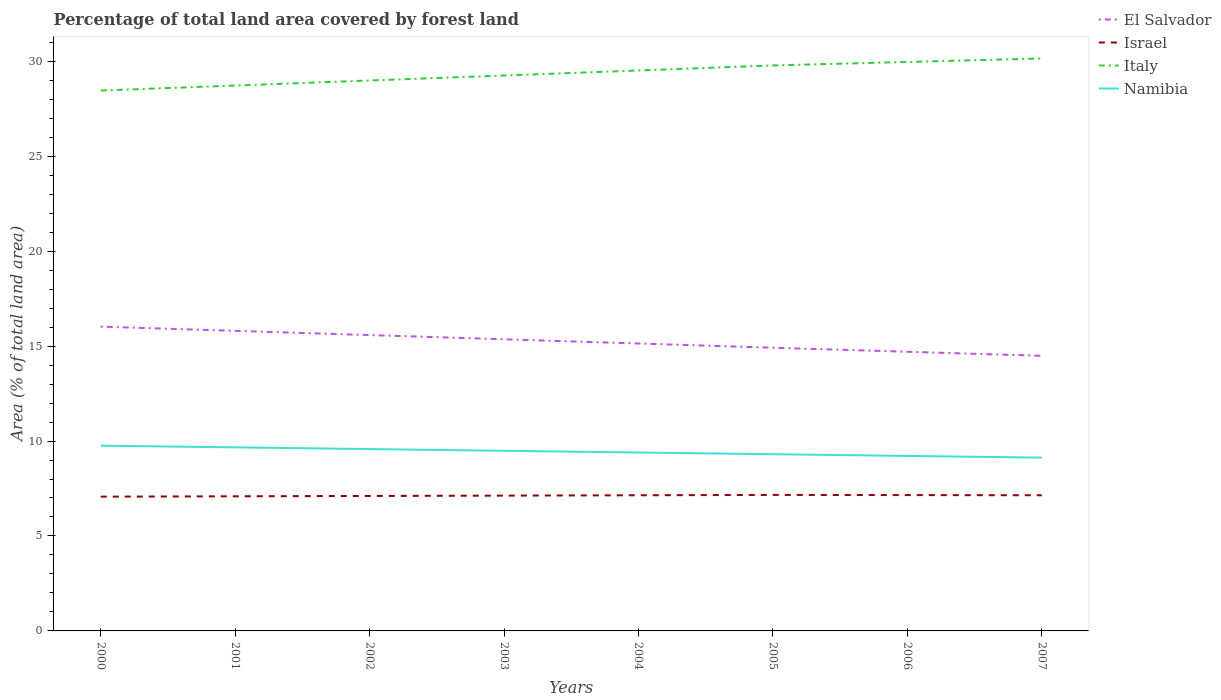How many different coloured lines are there?
Your answer should be compact. 4. Is the number of lines equal to the number of legend labels?
Provide a short and direct response. Yes. Across all years, what is the maximum percentage of forest land in Italy?
Provide a succinct answer. 28.46. In which year was the percentage of forest land in Namibia maximum?
Give a very brief answer. 2007. What is the total percentage of forest land in Israel in the graph?
Offer a terse response. -0.06. What is the difference between the highest and the second highest percentage of forest land in El Salvador?
Ensure brevity in your answer.  1.53. How many lines are there?
Offer a terse response. 4. How many years are there in the graph?
Provide a short and direct response. 8. Does the graph contain any zero values?
Provide a succinct answer. No. Does the graph contain grids?
Keep it short and to the point. No. How many legend labels are there?
Your response must be concise. 4. How are the legend labels stacked?
Your answer should be very brief. Vertical. What is the title of the graph?
Provide a short and direct response. Percentage of total land area covered by forest land. Does "Korea (Republic)" appear as one of the legend labels in the graph?
Your answer should be very brief. No. What is the label or title of the Y-axis?
Provide a succinct answer. Area (% of total land area). What is the Area (% of total land area) in El Salvador in 2000?
Offer a very short reply. 16.02. What is the Area (% of total land area) in Israel in 2000?
Ensure brevity in your answer.  7.07. What is the Area (% of total land area) in Italy in 2000?
Keep it short and to the point. 28.46. What is the Area (% of total land area) in Namibia in 2000?
Provide a short and direct response. 9.76. What is the Area (% of total land area) of El Salvador in 2001?
Provide a succinct answer. 15.8. What is the Area (% of total land area) of Israel in 2001?
Provide a succinct answer. 7.09. What is the Area (% of total land area) in Italy in 2001?
Offer a terse response. 28.72. What is the Area (% of total land area) of Namibia in 2001?
Offer a terse response. 9.67. What is the Area (% of total land area) of El Salvador in 2002?
Ensure brevity in your answer.  15.58. What is the Area (% of total land area) of Israel in 2002?
Offer a terse response. 7.11. What is the Area (% of total land area) in Italy in 2002?
Give a very brief answer. 28.99. What is the Area (% of total land area) in Namibia in 2002?
Provide a succinct answer. 9.58. What is the Area (% of total land area) in El Salvador in 2003?
Provide a short and direct response. 15.36. What is the Area (% of total land area) in Israel in 2003?
Make the answer very short. 7.13. What is the Area (% of total land area) of Italy in 2003?
Provide a short and direct response. 29.25. What is the Area (% of total land area) of Namibia in 2003?
Your answer should be compact. 9.49. What is the Area (% of total land area) in El Salvador in 2004?
Keep it short and to the point. 15.14. What is the Area (% of total land area) in Israel in 2004?
Make the answer very short. 7.14. What is the Area (% of total land area) in Italy in 2004?
Ensure brevity in your answer.  29.51. What is the Area (% of total land area) in Namibia in 2004?
Ensure brevity in your answer.  9.4. What is the Area (% of total land area) in El Salvador in 2005?
Keep it short and to the point. 14.91. What is the Area (% of total land area) of Israel in 2005?
Offer a very short reply. 7.16. What is the Area (% of total land area) of Italy in 2005?
Your response must be concise. 29.78. What is the Area (% of total land area) in Namibia in 2005?
Provide a short and direct response. 9.31. What is the Area (% of total land area) in El Salvador in 2006?
Make the answer very short. 14.7. What is the Area (% of total land area) in Israel in 2006?
Your response must be concise. 7.15. What is the Area (% of total land area) of Italy in 2006?
Ensure brevity in your answer.  29.96. What is the Area (% of total land area) of Namibia in 2006?
Your answer should be compact. 9.22. What is the Area (% of total land area) of El Salvador in 2007?
Offer a very short reply. 14.49. What is the Area (% of total land area) in Israel in 2007?
Give a very brief answer. 7.14. What is the Area (% of total land area) of Italy in 2007?
Offer a terse response. 30.14. What is the Area (% of total land area) of Namibia in 2007?
Provide a succinct answer. 9.13. Across all years, what is the maximum Area (% of total land area) of El Salvador?
Give a very brief answer. 16.02. Across all years, what is the maximum Area (% of total land area) in Israel?
Provide a succinct answer. 7.16. Across all years, what is the maximum Area (% of total land area) in Italy?
Offer a terse response. 30.14. Across all years, what is the maximum Area (% of total land area) of Namibia?
Your answer should be very brief. 9.76. Across all years, what is the minimum Area (% of total land area) of El Salvador?
Make the answer very short. 14.49. Across all years, what is the minimum Area (% of total land area) in Israel?
Offer a terse response. 7.07. Across all years, what is the minimum Area (% of total land area) of Italy?
Provide a short and direct response. 28.46. Across all years, what is the minimum Area (% of total land area) in Namibia?
Provide a short and direct response. 9.13. What is the total Area (% of total land area) of El Salvador in the graph?
Keep it short and to the point. 122. What is the total Area (% of total land area) of Israel in the graph?
Keep it short and to the point. 57. What is the total Area (% of total land area) in Italy in the graph?
Provide a short and direct response. 234.81. What is the total Area (% of total land area) of Namibia in the graph?
Your answer should be compact. 75.52. What is the difference between the Area (% of total land area) of El Salvador in 2000 and that in 2001?
Offer a very short reply. 0.22. What is the difference between the Area (% of total land area) of Israel in 2000 and that in 2001?
Provide a short and direct response. -0.02. What is the difference between the Area (% of total land area) of Italy in 2000 and that in 2001?
Make the answer very short. -0.27. What is the difference between the Area (% of total land area) in Namibia in 2000 and that in 2001?
Ensure brevity in your answer.  0.09. What is the difference between the Area (% of total land area) in El Salvador in 2000 and that in 2002?
Ensure brevity in your answer.  0.44. What is the difference between the Area (% of total land area) of Israel in 2000 and that in 2002?
Offer a very short reply. -0.04. What is the difference between the Area (% of total land area) in Italy in 2000 and that in 2002?
Offer a very short reply. -0.53. What is the difference between the Area (% of total land area) in Namibia in 2000 and that in 2002?
Provide a short and direct response. 0.18. What is the difference between the Area (% of total land area) in El Salvador in 2000 and that in 2003?
Provide a short and direct response. 0.67. What is the difference between the Area (% of total land area) in Israel in 2000 and that in 2003?
Ensure brevity in your answer.  -0.06. What is the difference between the Area (% of total land area) in Italy in 2000 and that in 2003?
Give a very brief answer. -0.79. What is the difference between the Area (% of total land area) in Namibia in 2000 and that in 2003?
Your response must be concise. 0.27. What is the difference between the Area (% of total land area) in El Salvador in 2000 and that in 2004?
Offer a terse response. 0.89. What is the difference between the Area (% of total land area) of Israel in 2000 and that in 2004?
Your answer should be very brief. -0.07. What is the difference between the Area (% of total land area) in Italy in 2000 and that in 2004?
Give a very brief answer. -1.06. What is the difference between the Area (% of total land area) in Namibia in 2000 and that in 2004?
Your answer should be very brief. 0.36. What is the difference between the Area (% of total land area) of El Salvador in 2000 and that in 2005?
Ensure brevity in your answer.  1.11. What is the difference between the Area (% of total land area) in Israel in 2000 and that in 2005?
Your answer should be compact. -0.09. What is the difference between the Area (% of total land area) in Italy in 2000 and that in 2005?
Give a very brief answer. -1.32. What is the difference between the Area (% of total land area) in Namibia in 2000 and that in 2005?
Offer a very short reply. 0.45. What is the difference between the Area (% of total land area) of El Salvador in 2000 and that in 2006?
Offer a very short reply. 1.32. What is the difference between the Area (% of total land area) of Israel in 2000 and that in 2006?
Your answer should be very brief. -0.08. What is the difference between the Area (% of total land area) of Italy in 2000 and that in 2006?
Give a very brief answer. -1.51. What is the difference between the Area (% of total land area) of Namibia in 2000 and that in 2006?
Give a very brief answer. 0.54. What is the difference between the Area (% of total land area) of El Salvador in 2000 and that in 2007?
Offer a terse response. 1.53. What is the difference between the Area (% of total land area) of Israel in 2000 and that in 2007?
Your answer should be very brief. -0.07. What is the difference between the Area (% of total land area) of Italy in 2000 and that in 2007?
Your answer should be compact. -1.69. What is the difference between the Area (% of total land area) in Namibia in 2000 and that in 2007?
Make the answer very short. 0.63. What is the difference between the Area (% of total land area) in El Salvador in 2001 and that in 2002?
Offer a very short reply. 0.22. What is the difference between the Area (% of total land area) in Israel in 2001 and that in 2002?
Your answer should be compact. -0.02. What is the difference between the Area (% of total land area) in Italy in 2001 and that in 2002?
Ensure brevity in your answer.  -0.27. What is the difference between the Area (% of total land area) of Namibia in 2001 and that in 2002?
Your response must be concise. 0.09. What is the difference between the Area (% of total land area) in El Salvador in 2001 and that in 2003?
Your answer should be very brief. 0.44. What is the difference between the Area (% of total land area) of Israel in 2001 and that in 2003?
Offer a terse response. -0.04. What is the difference between the Area (% of total land area) in Italy in 2001 and that in 2003?
Keep it short and to the point. -0.53. What is the difference between the Area (% of total land area) of Namibia in 2001 and that in 2003?
Offer a very short reply. 0.18. What is the difference between the Area (% of total land area) of El Salvador in 2001 and that in 2004?
Make the answer very short. 0.67. What is the difference between the Area (% of total land area) of Israel in 2001 and that in 2004?
Your response must be concise. -0.06. What is the difference between the Area (% of total land area) of Italy in 2001 and that in 2004?
Keep it short and to the point. -0.79. What is the difference between the Area (% of total land area) of Namibia in 2001 and that in 2004?
Offer a terse response. 0.27. What is the difference between the Area (% of total land area) in El Salvador in 2001 and that in 2005?
Your answer should be compact. 0.89. What is the difference between the Area (% of total land area) in Israel in 2001 and that in 2005?
Make the answer very short. -0.07. What is the difference between the Area (% of total land area) in Italy in 2001 and that in 2005?
Give a very brief answer. -1.06. What is the difference between the Area (% of total land area) of Namibia in 2001 and that in 2005?
Your response must be concise. 0.36. What is the difference between the Area (% of total land area) in El Salvador in 2001 and that in 2006?
Ensure brevity in your answer.  1.1. What is the difference between the Area (% of total land area) in Israel in 2001 and that in 2006?
Provide a succinct answer. -0.06. What is the difference between the Area (% of total land area) in Italy in 2001 and that in 2006?
Provide a short and direct response. -1.24. What is the difference between the Area (% of total land area) in Namibia in 2001 and that in 2006?
Ensure brevity in your answer.  0.45. What is the difference between the Area (% of total land area) in El Salvador in 2001 and that in 2007?
Your answer should be compact. 1.31. What is the difference between the Area (% of total land area) of Israel in 2001 and that in 2007?
Keep it short and to the point. -0.06. What is the difference between the Area (% of total land area) of Italy in 2001 and that in 2007?
Keep it short and to the point. -1.42. What is the difference between the Area (% of total land area) of Namibia in 2001 and that in 2007?
Provide a short and direct response. 0.54. What is the difference between the Area (% of total land area) of El Salvador in 2002 and that in 2003?
Keep it short and to the point. 0.22. What is the difference between the Area (% of total land area) in Israel in 2002 and that in 2003?
Ensure brevity in your answer.  -0.02. What is the difference between the Area (% of total land area) of Italy in 2002 and that in 2003?
Give a very brief answer. -0.26. What is the difference between the Area (% of total land area) in Namibia in 2002 and that in 2003?
Ensure brevity in your answer.  0.09. What is the difference between the Area (% of total land area) in El Salvador in 2002 and that in 2004?
Provide a succinct answer. 0.44. What is the difference between the Area (% of total land area) in Israel in 2002 and that in 2004?
Offer a very short reply. -0.04. What is the difference between the Area (% of total land area) in Italy in 2002 and that in 2004?
Provide a short and direct response. -0.53. What is the difference between the Area (% of total land area) of Namibia in 2002 and that in 2004?
Provide a succinct answer. 0.18. What is the difference between the Area (% of total land area) of El Salvador in 2002 and that in 2005?
Your answer should be compact. 0.67. What is the difference between the Area (% of total land area) in Israel in 2002 and that in 2005?
Your answer should be very brief. -0.06. What is the difference between the Area (% of total land area) in Italy in 2002 and that in 2005?
Keep it short and to the point. -0.79. What is the difference between the Area (% of total land area) in Namibia in 2002 and that in 2005?
Your answer should be compact. 0.27. What is the difference between the Area (% of total land area) in El Salvador in 2002 and that in 2006?
Keep it short and to the point. 0.88. What is the difference between the Area (% of total land area) of Israel in 2002 and that in 2006?
Provide a short and direct response. -0.05. What is the difference between the Area (% of total land area) in Italy in 2002 and that in 2006?
Offer a terse response. -0.98. What is the difference between the Area (% of total land area) in Namibia in 2002 and that in 2006?
Offer a very short reply. 0.36. What is the difference between the Area (% of total land area) of El Salvador in 2002 and that in 2007?
Give a very brief answer. 1.09. What is the difference between the Area (% of total land area) in Israel in 2002 and that in 2007?
Keep it short and to the point. -0.04. What is the difference between the Area (% of total land area) in Italy in 2002 and that in 2007?
Your response must be concise. -1.16. What is the difference between the Area (% of total land area) in Namibia in 2002 and that in 2007?
Your answer should be compact. 0.45. What is the difference between the Area (% of total land area) of El Salvador in 2003 and that in 2004?
Your answer should be very brief. 0.22. What is the difference between the Area (% of total land area) of Israel in 2003 and that in 2004?
Provide a succinct answer. -0.02. What is the difference between the Area (% of total land area) of Italy in 2003 and that in 2004?
Your response must be concise. -0.27. What is the difference between the Area (% of total land area) of Namibia in 2003 and that in 2004?
Your answer should be very brief. 0.09. What is the difference between the Area (% of total land area) in El Salvador in 2003 and that in 2005?
Make the answer very short. 0.44. What is the difference between the Area (% of total land area) of Israel in 2003 and that in 2005?
Your response must be concise. -0.04. What is the difference between the Area (% of total land area) of Italy in 2003 and that in 2005?
Your answer should be compact. -0.53. What is the difference between the Area (% of total land area) in Namibia in 2003 and that in 2005?
Give a very brief answer. 0.18. What is the difference between the Area (% of total land area) in El Salvador in 2003 and that in 2006?
Offer a very short reply. 0.66. What is the difference between the Area (% of total land area) in Israel in 2003 and that in 2006?
Keep it short and to the point. -0.03. What is the difference between the Area (% of total land area) in Italy in 2003 and that in 2006?
Your answer should be compact. -0.71. What is the difference between the Area (% of total land area) of Namibia in 2003 and that in 2006?
Your answer should be compact. 0.27. What is the difference between the Area (% of total land area) of El Salvador in 2003 and that in 2007?
Keep it short and to the point. 0.87. What is the difference between the Area (% of total land area) of Israel in 2003 and that in 2007?
Ensure brevity in your answer.  -0.02. What is the difference between the Area (% of total land area) in Italy in 2003 and that in 2007?
Make the answer very short. -0.9. What is the difference between the Area (% of total land area) of Namibia in 2003 and that in 2007?
Make the answer very short. 0.36. What is the difference between the Area (% of total land area) of El Salvador in 2004 and that in 2005?
Ensure brevity in your answer.  0.22. What is the difference between the Area (% of total land area) of Israel in 2004 and that in 2005?
Offer a very short reply. -0.02. What is the difference between the Area (% of total land area) of Italy in 2004 and that in 2005?
Your response must be concise. -0.27. What is the difference between the Area (% of total land area) in Namibia in 2004 and that in 2005?
Keep it short and to the point. 0.09. What is the difference between the Area (% of total land area) of El Salvador in 2004 and that in 2006?
Provide a short and direct response. 0.43. What is the difference between the Area (% of total land area) of Israel in 2004 and that in 2006?
Give a very brief answer. -0.01. What is the difference between the Area (% of total land area) in Italy in 2004 and that in 2006?
Provide a succinct answer. -0.45. What is the difference between the Area (% of total land area) of Namibia in 2004 and that in 2006?
Your response must be concise. 0.18. What is the difference between the Area (% of total land area) in El Salvador in 2004 and that in 2007?
Offer a very short reply. 0.65. What is the difference between the Area (% of total land area) of Israel in 2004 and that in 2007?
Provide a succinct answer. 0. What is the difference between the Area (% of total land area) in Italy in 2004 and that in 2007?
Give a very brief answer. -0.63. What is the difference between the Area (% of total land area) in Namibia in 2004 and that in 2007?
Provide a succinct answer. 0.27. What is the difference between the Area (% of total land area) of El Salvador in 2005 and that in 2006?
Provide a short and direct response. 0.21. What is the difference between the Area (% of total land area) in Israel in 2005 and that in 2006?
Your answer should be compact. 0.01. What is the difference between the Area (% of total land area) in Italy in 2005 and that in 2006?
Provide a short and direct response. -0.18. What is the difference between the Area (% of total land area) in Namibia in 2005 and that in 2006?
Keep it short and to the point. 0.09. What is the difference between the Area (% of total land area) in El Salvador in 2005 and that in 2007?
Provide a succinct answer. 0.42. What is the difference between the Area (% of total land area) in Israel in 2005 and that in 2007?
Give a very brief answer. 0.02. What is the difference between the Area (% of total land area) in Italy in 2005 and that in 2007?
Offer a very short reply. -0.37. What is the difference between the Area (% of total land area) in Namibia in 2005 and that in 2007?
Make the answer very short. 0.18. What is the difference between the Area (% of total land area) in El Salvador in 2006 and that in 2007?
Your answer should be very brief. 0.21. What is the difference between the Area (% of total land area) of Israel in 2006 and that in 2007?
Keep it short and to the point. 0.01. What is the difference between the Area (% of total land area) of Italy in 2006 and that in 2007?
Offer a very short reply. -0.18. What is the difference between the Area (% of total land area) in Namibia in 2006 and that in 2007?
Keep it short and to the point. 0.09. What is the difference between the Area (% of total land area) in El Salvador in 2000 and the Area (% of total land area) in Israel in 2001?
Keep it short and to the point. 8.93. What is the difference between the Area (% of total land area) of El Salvador in 2000 and the Area (% of total land area) of Italy in 2001?
Your answer should be compact. -12.7. What is the difference between the Area (% of total land area) in El Salvador in 2000 and the Area (% of total land area) in Namibia in 2001?
Ensure brevity in your answer.  6.36. What is the difference between the Area (% of total land area) in Israel in 2000 and the Area (% of total land area) in Italy in 2001?
Offer a very short reply. -21.65. What is the difference between the Area (% of total land area) in Israel in 2000 and the Area (% of total land area) in Namibia in 2001?
Ensure brevity in your answer.  -2.6. What is the difference between the Area (% of total land area) of Italy in 2000 and the Area (% of total land area) of Namibia in 2001?
Keep it short and to the point. 18.79. What is the difference between the Area (% of total land area) of El Salvador in 2000 and the Area (% of total land area) of Israel in 2002?
Make the answer very short. 8.92. What is the difference between the Area (% of total land area) in El Salvador in 2000 and the Area (% of total land area) in Italy in 2002?
Make the answer very short. -12.96. What is the difference between the Area (% of total land area) of El Salvador in 2000 and the Area (% of total land area) of Namibia in 2002?
Offer a terse response. 6.45. What is the difference between the Area (% of total land area) of Israel in 2000 and the Area (% of total land area) of Italy in 2002?
Give a very brief answer. -21.92. What is the difference between the Area (% of total land area) of Israel in 2000 and the Area (% of total land area) of Namibia in 2002?
Provide a succinct answer. -2.51. What is the difference between the Area (% of total land area) of Italy in 2000 and the Area (% of total land area) of Namibia in 2002?
Your answer should be compact. 18.88. What is the difference between the Area (% of total land area) of El Salvador in 2000 and the Area (% of total land area) of Israel in 2003?
Your answer should be very brief. 8.9. What is the difference between the Area (% of total land area) of El Salvador in 2000 and the Area (% of total land area) of Italy in 2003?
Give a very brief answer. -13.22. What is the difference between the Area (% of total land area) in El Salvador in 2000 and the Area (% of total land area) in Namibia in 2003?
Offer a very short reply. 6.54. What is the difference between the Area (% of total land area) of Israel in 2000 and the Area (% of total land area) of Italy in 2003?
Ensure brevity in your answer.  -22.18. What is the difference between the Area (% of total land area) in Israel in 2000 and the Area (% of total land area) in Namibia in 2003?
Offer a terse response. -2.42. What is the difference between the Area (% of total land area) of Italy in 2000 and the Area (% of total land area) of Namibia in 2003?
Provide a short and direct response. 18.97. What is the difference between the Area (% of total land area) of El Salvador in 2000 and the Area (% of total land area) of Israel in 2004?
Give a very brief answer. 8.88. What is the difference between the Area (% of total land area) of El Salvador in 2000 and the Area (% of total land area) of Italy in 2004?
Make the answer very short. -13.49. What is the difference between the Area (% of total land area) in El Salvador in 2000 and the Area (% of total land area) in Namibia in 2004?
Your answer should be very brief. 6.63. What is the difference between the Area (% of total land area) in Israel in 2000 and the Area (% of total land area) in Italy in 2004?
Your response must be concise. -22.44. What is the difference between the Area (% of total land area) of Israel in 2000 and the Area (% of total land area) of Namibia in 2004?
Your answer should be very brief. -2.33. What is the difference between the Area (% of total land area) in Italy in 2000 and the Area (% of total land area) in Namibia in 2004?
Your answer should be very brief. 19.06. What is the difference between the Area (% of total land area) in El Salvador in 2000 and the Area (% of total land area) in Israel in 2005?
Offer a terse response. 8.86. What is the difference between the Area (% of total land area) of El Salvador in 2000 and the Area (% of total land area) of Italy in 2005?
Your answer should be compact. -13.76. What is the difference between the Area (% of total land area) of El Salvador in 2000 and the Area (% of total land area) of Namibia in 2005?
Offer a terse response. 6.72. What is the difference between the Area (% of total land area) in Israel in 2000 and the Area (% of total land area) in Italy in 2005?
Your answer should be very brief. -22.71. What is the difference between the Area (% of total land area) in Israel in 2000 and the Area (% of total land area) in Namibia in 2005?
Provide a short and direct response. -2.24. What is the difference between the Area (% of total land area) of Italy in 2000 and the Area (% of total land area) of Namibia in 2005?
Your answer should be compact. 19.15. What is the difference between the Area (% of total land area) in El Salvador in 2000 and the Area (% of total land area) in Israel in 2006?
Your answer should be very brief. 8.87. What is the difference between the Area (% of total land area) in El Salvador in 2000 and the Area (% of total land area) in Italy in 2006?
Provide a short and direct response. -13.94. What is the difference between the Area (% of total land area) in El Salvador in 2000 and the Area (% of total land area) in Namibia in 2006?
Offer a terse response. 6.81. What is the difference between the Area (% of total land area) of Israel in 2000 and the Area (% of total land area) of Italy in 2006?
Offer a very short reply. -22.89. What is the difference between the Area (% of total land area) in Israel in 2000 and the Area (% of total land area) in Namibia in 2006?
Your answer should be very brief. -2.15. What is the difference between the Area (% of total land area) of Italy in 2000 and the Area (% of total land area) of Namibia in 2006?
Offer a very short reply. 19.24. What is the difference between the Area (% of total land area) in El Salvador in 2000 and the Area (% of total land area) in Israel in 2007?
Your response must be concise. 8.88. What is the difference between the Area (% of total land area) in El Salvador in 2000 and the Area (% of total land area) in Italy in 2007?
Your answer should be compact. -14.12. What is the difference between the Area (% of total land area) in El Salvador in 2000 and the Area (% of total land area) in Namibia in 2007?
Your response must be concise. 6.9. What is the difference between the Area (% of total land area) of Israel in 2000 and the Area (% of total land area) of Italy in 2007?
Offer a terse response. -23.07. What is the difference between the Area (% of total land area) of Israel in 2000 and the Area (% of total land area) of Namibia in 2007?
Offer a very short reply. -2.05. What is the difference between the Area (% of total land area) in Italy in 2000 and the Area (% of total land area) in Namibia in 2007?
Your response must be concise. 19.33. What is the difference between the Area (% of total land area) in El Salvador in 2001 and the Area (% of total land area) in Israel in 2002?
Offer a terse response. 8.69. What is the difference between the Area (% of total land area) in El Salvador in 2001 and the Area (% of total land area) in Italy in 2002?
Make the answer very short. -13.18. What is the difference between the Area (% of total land area) in El Salvador in 2001 and the Area (% of total land area) in Namibia in 2002?
Give a very brief answer. 6.23. What is the difference between the Area (% of total land area) of Israel in 2001 and the Area (% of total land area) of Italy in 2002?
Give a very brief answer. -21.9. What is the difference between the Area (% of total land area) in Israel in 2001 and the Area (% of total land area) in Namibia in 2002?
Your answer should be very brief. -2.49. What is the difference between the Area (% of total land area) in Italy in 2001 and the Area (% of total land area) in Namibia in 2002?
Your answer should be very brief. 19.14. What is the difference between the Area (% of total land area) in El Salvador in 2001 and the Area (% of total land area) in Israel in 2003?
Ensure brevity in your answer.  8.68. What is the difference between the Area (% of total land area) of El Salvador in 2001 and the Area (% of total land area) of Italy in 2003?
Offer a very short reply. -13.45. What is the difference between the Area (% of total land area) in El Salvador in 2001 and the Area (% of total land area) in Namibia in 2003?
Make the answer very short. 6.32. What is the difference between the Area (% of total land area) of Israel in 2001 and the Area (% of total land area) of Italy in 2003?
Your answer should be very brief. -22.16. What is the difference between the Area (% of total land area) in Israel in 2001 and the Area (% of total land area) in Namibia in 2003?
Keep it short and to the point. -2.4. What is the difference between the Area (% of total land area) of Italy in 2001 and the Area (% of total land area) of Namibia in 2003?
Make the answer very short. 19.23. What is the difference between the Area (% of total land area) in El Salvador in 2001 and the Area (% of total land area) in Israel in 2004?
Ensure brevity in your answer.  8.66. What is the difference between the Area (% of total land area) in El Salvador in 2001 and the Area (% of total land area) in Italy in 2004?
Make the answer very short. -13.71. What is the difference between the Area (% of total land area) in El Salvador in 2001 and the Area (% of total land area) in Namibia in 2004?
Your answer should be compact. 6.41. What is the difference between the Area (% of total land area) of Israel in 2001 and the Area (% of total land area) of Italy in 2004?
Your response must be concise. -22.42. What is the difference between the Area (% of total land area) of Israel in 2001 and the Area (% of total land area) of Namibia in 2004?
Make the answer very short. -2.31. What is the difference between the Area (% of total land area) of Italy in 2001 and the Area (% of total land area) of Namibia in 2004?
Ensure brevity in your answer.  19.33. What is the difference between the Area (% of total land area) in El Salvador in 2001 and the Area (% of total land area) in Israel in 2005?
Keep it short and to the point. 8.64. What is the difference between the Area (% of total land area) in El Salvador in 2001 and the Area (% of total land area) in Italy in 2005?
Your answer should be compact. -13.98. What is the difference between the Area (% of total land area) in El Salvador in 2001 and the Area (% of total land area) in Namibia in 2005?
Ensure brevity in your answer.  6.5. What is the difference between the Area (% of total land area) of Israel in 2001 and the Area (% of total land area) of Italy in 2005?
Your answer should be very brief. -22.69. What is the difference between the Area (% of total land area) in Israel in 2001 and the Area (% of total land area) in Namibia in 2005?
Give a very brief answer. -2.22. What is the difference between the Area (% of total land area) of Italy in 2001 and the Area (% of total land area) of Namibia in 2005?
Give a very brief answer. 19.42. What is the difference between the Area (% of total land area) in El Salvador in 2001 and the Area (% of total land area) in Israel in 2006?
Ensure brevity in your answer.  8.65. What is the difference between the Area (% of total land area) of El Salvador in 2001 and the Area (% of total land area) of Italy in 2006?
Provide a short and direct response. -14.16. What is the difference between the Area (% of total land area) of El Salvador in 2001 and the Area (% of total land area) of Namibia in 2006?
Provide a short and direct response. 6.59. What is the difference between the Area (% of total land area) of Israel in 2001 and the Area (% of total land area) of Italy in 2006?
Offer a very short reply. -22.87. What is the difference between the Area (% of total land area) in Israel in 2001 and the Area (% of total land area) in Namibia in 2006?
Provide a short and direct response. -2.13. What is the difference between the Area (% of total land area) in Italy in 2001 and the Area (% of total land area) in Namibia in 2006?
Keep it short and to the point. 19.51. What is the difference between the Area (% of total land area) of El Salvador in 2001 and the Area (% of total land area) of Israel in 2007?
Provide a short and direct response. 8.66. What is the difference between the Area (% of total land area) of El Salvador in 2001 and the Area (% of total land area) of Italy in 2007?
Your response must be concise. -14.34. What is the difference between the Area (% of total land area) of El Salvador in 2001 and the Area (% of total land area) of Namibia in 2007?
Give a very brief answer. 6.68. What is the difference between the Area (% of total land area) in Israel in 2001 and the Area (% of total land area) in Italy in 2007?
Ensure brevity in your answer.  -23.06. What is the difference between the Area (% of total land area) of Israel in 2001 and the Area (% of total land area) of Namibia in 2007?
Provide a succinct answer. -2.04. What is the difference between the Area (% of total land area) of Italy in 2001 and the Area (% of total land area) of Namibia in 2007?
Give a very brief answer. 19.6. What is the difference between the Area (% of total land area) in El Salvador in 2002 and the Area (% of total land area) in Israel in 2003?
Provide a succinct answer. 8.45. What is the difference between the Area (% of total land area) in El Salvador in 2002 and the Area (% of total land area) in Italy in 2003?
Provide a succinct answer. -13.67. What is the difference between the Area (% of total land area) of El Salvador in 2002 and the Area (% of total land area) of Namibia in 2003?
Keep it short and to the point. 6.09. What is the difference between the Area (% of total land area) of Israel in 2002 and the Area (% of total land area) of Italy in 2003?
Your response must be concise. -22.14. What is the difference between the Area (% of total land area) in Israel in 2002 and the Area (% of total land area) in Namibia in 2003?
Your answer should be compact. -2.38. What is the difference between the Area (% of total land area) of Italy in 2002 and the Area (% of total land area) of Namibia in 2003?
Your response must be concise. 19.5. What is the difference between the Area (% of total land area) in El Salvador in 2002 and the Area (% of total land area) in Israel in 2004?
Your answer should be very brief. 8.44. What is the difference between the Area (% of total land area) in El Salvador in 2002 and the Area (% of total land area) in Italy in 2004?
Provide a short and direct response. -13.93. What is the difference between the Area (% of total land area) in El Salvador in 2002 and the Area (% of total land area) in Namibia in 2004?
Your response must be concise. 6.18. What is the difference between the Area (% of total land area) in Israel in 2002 and the Area (% of total land area) in Italy in 2004?
Your answer should be very brief. -22.41. What is the difference between the Area (% of total land area) in Israel in 2002 and the Area (% of total land area) in Namibia in 2004?
Make the answer very short. -2.29. What is the difference between the Area (% of total land area) of Italy in 2002 and the Area (% of total land area) of Namibia in 2004?
Keep it short and to the point. 19.59. What is the difference between the Area (% of total land area) in El Salvador in 2002 and the Area (% of total land area) in Israel in 2005?
Ensure brevity in your answer.  8.42. What is the difference between the Area (% of total land area) of El Salvador in 2002 and the Area (% of total land area) of Italy in 2005?
Offer a terse response. -14.2. What is the difference between the Area (% of total land area) of El Salvador in 2002 and the Area (% of total land area) of Namibia in 2005?
Your answer should be very brief. 6.27. What is the difference between the Area (% of total land area) of Israel in 2002 and the Area (% of total land area) of Italy in 2005?
Your answer should be very brief. -22.67. What is the difference between the Area (% of total land area) in Israel in 2002 and the Area (% of total land area) in Namibia in 2005?
Your response must be concise. -2.2. What is the difference between the Area (% of total land area) in Italy in 2002 and the Area (% of total land area) in Namibia in 2005?
Offer a very short reply. 19.68. What is the difference between the Area (% of total land area) of El Salvador in 2002 and the Area (% of total land area) of Israel in 2006?
Keep it short and to the point. 8.43. What is the difference between the Area (% of total land area) of El Salvador in 2002 and the Area (% of total land area) of Italy in 2006?
Give a very brief answer. -14.38. What is the difference between the Area (% of total land area) in El Salvador in 2002 and the Area (% of total land area) in Namibia in 2006?
Give a very brief answer. 6.36. What is the difference between the Area (% of total land area) in Israel in 2002 and the Area (% of total land area) in Italy in 2006?
Provide a short and direct response. -22.85. What is the difference between the Area (% of total land area) in Israel in 2002 and the Area (% of total land area) in Namibia in 2006?
Your response must be concise. -2.11. What is the difference between the Area (% of total land area) in Italy in 2002 and the Area (% of total land area) in Namibia in 2006?
Keep it short and to the point. 19.77. What is the difference between the Area (% of total land area) in El Salvador in 2002 and the Area (% of total land area) in Israel in 2007?
Offer a terse response. 8.44. What is the difference between the Area (% of total land area) in El Salvador in 2002 and the Area (% of total land area) in Italy in 2007?
Offer a very short reply. -14.56. What is the difference between the Area (% of total land area) in El Salvador in 2002 and the Area (% of total land area) in Namibia in 2007?
Provide a short and direct response. 6.45. What is the difference between the Area (% of total land area) in Israel in 2002 and the Area (% of total land area) in Italy in 2007?
Keep it short and to the point. -23.04. What is the difference between the Area (% of total land area) of Israel in 2002 and the Area (% of total land area) of Namibia in 2007?
Provide a short and direct response. -2.02. What is the difference between the Area (% of total land area) in Italy in 2002 and the Area (% of total land area) in Namibia in 2007?
Keep it short and to the point. 19.86. What is the difference between the Area (% of total land area) in El Salvador in 2003 and the Area (% of total land area) in Israel in 2004?
Your response must be concise. 8.21. What is the difference between the Area (% of total land area) in El Salvador in 2003 and the Area (% of total land area) in Italy in 2004?
Give a very brief answer. -14.16. What is the difference between the Area (% of total land area) of El Salvador in 2003 and the Area (% of total land area) of Namibia in 2004?
Offer a terse response. 5.96. What is the difference between the Area (% of total land area) of Israel in 2003 and the Area (% of total land area) of Italy in 2004?
Provide a short and direct response. -22.39. What is the difference between the Area (% of total land area) in Israel in 2003 and the Area (% of total land area) in Namibia in 2004?
Provide a short and direct response. -2.27. What is the difference between the Area (% of total land area) of Italy in 2003 and the Area (% of total land area) of Namibia in 2004?
Give a very brief answer. 19.85. What is the difference between the Area (% of total land area) in El Salvador in 2003 and the Area (% of total land area) in Israel in 2005?
Your answer should be very brief. 8.19. What is the difference between the Area (% of total land area) in El Salvador in 2003 and the Area (% of total land area) in Italy in 2005?
Give a very brief answer. -14.42. What is the difference between the Area (% of total land area) of El Salvador in 2003 and the Area (% of total land area) of Namibia in 2005?
Offer a terse response. 6.05. What is the difference between the Area (% of total land area) of Israel in 2003 and the Area (% of total land area) of Italy in 2005?
Provide a short and direct response. -22.65. What is the difference between the Area (% of total land area) of Israel in 2003 and the Area (% of total land area) of Namibia in 2005?
Make the answer very short. -2.18. What is the difference between the Area (% of total land area) of Italy in 2003 and the Area (% of total land area) of Namibia in 2005?
Make the answer very short. 19.94. What is the difference between the Area (% of total land area) of El Salvador in 2003 and the Area (% of total land area) of Israel in 2006?
Keep it short and to the point. 8.2. What is the difference between the Area (% of total land area) of El Salvador in 2003 and the Area (% of total land area) of Italy in 2006?
Offer a very short reply. -14.6. What is the difference between the Area (% of total land area) in El Salvador in 2003 and the Area (% of total land area) in Namibia in 2006?
Provide a short and direct response. 6.14. What is the difference between the Area (% of total land area) in Israel in 2003 and the Area (% of total land area) in Italy in 2006?
Keep it short and to the point. -22.84. What is the difference between the Area (% of total land area) of Israel in 2003 and the Area (% of total land area) of Namibia in 2006?
Provide a short and direct response. -2.09. What is the difference between the Area (% of total land area) in Italy in 2003 and the Area (% of total land area) in Namibia in 2006?
Your answer should be very brief. 20.03. What is the difference between the Area (% of total land area) of El Salvador in 2003 and the Area (% of total land area) of Israel in 2007?
Make the answer very short. 8.21. What is the difference between the Area (% of total land area) in El Salvador in 2003 and the Area (% of total land area) in Italy in 2007?
Provide a succinct answer. -14.79. What is the difference between the Area (% of total land area) in El Salvador in 2003 and the Area (% of total land area) in Namibia in 2007?
Offer a very short reply. 6.23. What is the difference between the Area (% of total land area) in Israel in 2003 and the Area (% of total land area) in Italy in 2007?
Keep it short and to the point. -23.02. What is the difference between the Area (% of total land area) of Israel in 2003 and the Area (% of total land area) of Namibia in 2007?
Your answer should be very brief. -2. What is the difference between the Area (% of total land area) in Italy in 2003 and the Area (% of total land area) in Namibia in 2007?
Offer a terse response. 20.12. What is the difference between the Area (% of total land area) of El Salvador in 2004 and the Area (% of total land area) of Israel in 2005?
Your answer should be very brief. 7.97. What is the difference between the Area (% of total land area) of El Salvador in 2004 and the Area (% of total land area) of Italy in 2005?
Your answer should be very brief. -14.64. What is the difference between the Area (% of total land area) in El Salvador in 2004 and the Area (% of total land area) in Namibia in 2005?
Provide a succinct answer. 5.83. What is the difference between the Area (% of total land area) in Israel in 2004 and the Area (% of total land area) in Italy in 2005?
Give a very brief answer. -22.63. What is the difference between the Area (% of total land area) of Israel in 2004 and the Area (% of total land area) of Namibia in 2005?
Give a very brief answer. -2.16. What is the difference between the Area (% of total land area) of Italy in 2004 and the Area (% of total land area) of Namibia in 2005?
Offer a terse response. 20.21. What is the difference between the Area (% of total land area) of El Salvador in 2004 and the Area (% of total land area) of Israel in 2006?
Offer a very short reply. 7.98. What is the difference between the Area (% of total land area) in El Salvador in 2004 and the Area (% of total land area) in Italy in 2006?
Give a very brief answer. -14.83. What is the difference between the Area (% of total land area) of El Salvador in 2004 and the Area (% of total land area) of Namibia in 2006?
Provide a succinct answer. 5.92. What is the difference between the Area (% of total land area) in Israel in 2004 and the Area (% of total land area) in Italy in 2006?
Ensure brevity in your answer.  -22.82. What is the difference between the Area (% of total land area) of Israel in 2004 and the Area (% of total land area) of Namibia in 2006?
Your response must be concise. -2.07. What is the difference between the Area (% of total land area) of Italy in 2004 and the Area (% of total land area) of Namibia in 2006?
Offer a terse response. 20.3. What is the difference between the Area (% of total land area) in El Salvador in 2004 and the Area (% of total land area) in Israel in 2007?
Your answer should be compact. 7.99. What is the difference between the Area (% of total land area) in El Salvador in 2004 and the Area (% of total land area) in Italy in 2007?
Give a very brief answer. -15.01. What is the difference between the Area (% of total land area) of El Salvador in 2004 and the Area (% of total land area) of Namibia in 2007?
Make the answer very short. 6.01. What is the difference between the Area (% of total land area) in Israel in 2004 and the Area (% of total land area) in Namibia in 2007?
Your answer should be compact. -1.98. What is the difference between the Area (% of total land area) of Italy in 2004 and the Area (% of total land area) of Namibia in 2007?
Provide a short and direct response. 20.39. What is the difference between the Area (% of total land area) in El Salvador in 2005 and the Area (% of total land area) in Israel in 2006?
Provide a succinct answer. 7.76. What is the difference between the Area (% of total land area) of El Salvador in 2005 and the Area (% of total land area) of Italy in 2006?
Give a very brief answer. -15.05. What is the difference between the Area (% of total land area) of El Salvador in 2005 and the Area (% of total land area) of Namibia in 2006?
Your answer should be compact. 5.7. What is the difference between the Area (% of total land area) in Israel in 2005 and the Area (% of total land area) in Italy in 2006?
Keep it short and to the point. -22.8. What is the difference between the Area (% of total land area) in Israel in 2005 and the Area (% of total land area) in Namibia in 2006?
Give a very brief answer. -2.05. What is the difference between the Area (% of total land area) in Italy in 2005 and the Area (% of total land area) in Namibia in 2006?
Your response must be concise. 20.56. What is the difference between the Area (% of total land area) of El Salvador in 2005 and the Area (% of total land area) of Israel in 2007?
Keep it short and to the point. 7.77. What is the difference between the Area (% of total land area) of El Salvador in 2005 and the Area (% of total land area) of Italy in 2007?
Your response must be concise. -15.23. What is the difference between the Area (% of total land area) in El Salvador in 2005 and the Area (% of total land area) in Namibia in 2007?
Offer a terse response. 5.79. What is the difference between the Area (% of total land area) of Israel in 2005 and the Area (% of total land area) of Italy in 2007?
Your answer should be very brief. -22.98. What is the difference between the Area (% of total land area) of Israel in 2005 and the Area (% of total land area) of Namibia in 2007?
Keep it short and to the point. -1.96. What is the difference between the Area (% of total land area) of Italy in 2005 and the Area (% of total land area) of Namibia in 2007?
Offer a very short reply. 20.65. What is the difference between the Area (% of total land area) in El Salvador in 2006 and the Area (% of total land area) in Israel in 2007?
Ensure brevity in your answer.  7.56. What is the difference between the Area (% of total land area) of El Salvador in 2006 and the Area (% of total land area) of Italy in 2007?
Your answer should be very brief. -15.44. What is the difference between the Area (% of total land area) in El Salvador in 2006 and the Area (% of total land area) in Namibia in 2007?
Your answer should be very brief. 5.58. What is the difference between the Area (% of total land area) in Israel in 2006 and the Area (% of total land area) in Italy in 2007?
Your response must be concise. -22.99. What is the difference between the Area (% of total land area) in Israel in 2006 and the Area (% of total land area) in Namibia in 2007?
Your answer should be very brief. -1.97. What is the difference between the Area (% of total land area) of Italy in 2006 and the Area (% of total land area) of Namibia in 2007?
Give a very brief answer. 20.84. What is the average Area (% of total land area) of El Salvador per year?
Provide a succinct answer. 15.25. What is the average Area (% of total land area) in Israel per year?
Provide a short and direct response. 7.12. What is the average Area (% of total land area) of Italy per year?
Offer a very short reply. 29.35. What is the average Area (% of total land area) in Namibia per year?
Provide a succinct answer. 9.44. In the year 2000, what is the difference between the Area (% of total land area) of El Salvador and Area (% of total land area) of Israel?
Offer a terse response. 8.95. In the year 2000, what is the difference between the Area (% of total land area) of El Salvador and Area (% of total land area) of Italy?
Your response must be concise. -12.43. In the year 2000, what is the difference between the Area (% of total land area) in El Salvador and Area (% of total land area) in Namibia?
Offer a very short reply. 6.27. In the year 2000, what is the difference between the Area (% of total land area) of Israel and Area (% of total land area) of Italy?
Offer a terse response. -21.39. In the year 2000, what is the difference between the Area (% of total land area) in Israel and Area (% of total land area) in Namibia?
Offer a terse response. -2.69. In the year 2000, what is the difference between the Area (% of total land area) of Italy and Area (% of total land area) of Namibia?
Give a very brief answer. 18.7. In the year 2001, what is the difference between the Area (% of total land area) of El Salvador and Area (% of total land area) of Israel?
Offer a very short reply. 8.71. In the year 2001, what is the difference between the Area (% of total land area) of El Salvador and Area (% of total land area) of Italy?
Provide a short and direct response. -12.92. In the year 2001, what is the difference between the Area (% of total land area) in El Salvador and Area (% of total land area) in Namibia?
Ensure brevity in your answer.  6.14. In the year 2001, what is the difference between the Area (% of total land area) of Israel and Area (% of total land area) of Italy?
Provide a succinct answer. -21.63. In the year 2001, what is the difference between the Area (% of total land area) of Israel and Area (% of total land area) of Namibia?
Give a very brief answer. -2.58. In the year 2001, what is the difference between the Area (% of total land area) in Italy and Area (% of total land area) in Namibia?
Offer a terse response. 19.05. In the year 2002, what is the difference between the Area (% of total land area) in El Salvador and Area (% of total land area) in Israel?
Offer a very short reply. 8.47. In the year 2002, what is the difference between the Area (% of total land area) of El Salvador and Area (% of total land area) of Italy?
Ensure brevity in your answer.  -13.41. In the year 2002, what is the difference between the Area (% of total land area) in El Salvador and Area (% of total land area) in Namibia?
Provide a short and direct response. 6. In the year 2002, what is the difference between the Area (% of total land area) of Israel and Area (% of total land area) of Italy?
Ensure brevity in your answer.  -21.88. In the year 2002, what is the difference between the Area (% of total land area) of Israel and Area (% of total land area) of Namibia?
Your answer should be compact. -2.47. In the year 2002, what is the difference between the Area (% of total land area) of Italy and Area (% of total land area) of Namibia?
Keep it short and to the point. 19.41. In the year 2003, what is the difference between the Area (% of total land area) in El Salvador and Area (% of total land area) in Israel?
Give a very brief answer. 8.23. In the year 2003, what is the difference between the Area (% of total land area) of El Salvador and Area (% of total land area) of Italy?
Ensure brevity in your answer.  -13.89. In the year 2003, what is the difference between the Area (% of total land area) in El Salvador and Area (% of total land area) in Namibia?
Your answer should be compact. 5.87. In the year 2003, what is the difference between the Area (% of total land area) of Israel and Area (% of total land area) of Italy?
Your response must be concise. -22.12. In the year 2003, what is the difference between the Area (% of total land area) of Israel and Area (% of total land area) of Namibia?
Offer a terse response. -2.36. In the year 2003, what is the difference between the Area (% of total land area) in Italy and Area (% of total land area) in Namibia?
Your answer should be very brief. 19.76. In the year 2004, what is the difference between the Area (% of total land area) in El Salvador and Area (% of total land area) in Israel?
Give a very brief answer. 7.99. In the year 2004, what is the difference between the Area (% of total land area) of El Salvador and Area (% of total land area) of Italy?
Ensure brevity in your answer.  -14.38. In the year 2004, what is the difference between the Area (% of total land area) in El Salvador and Area (% of total land area) in Namibia?
Provide a short and direct response. 5.74. In the year 2004, what is the difference between the Area (% of total land area) in Israel and Area (% of total land area) in Italy?
Keep it short and to the point. -22.37. In the year 2004, what is the difference between the Area (% of total land area) in Israel and Area (% of total land area) in Namibia?
Make the answer very short. -2.25. In the year 2004, what is the difference between the Area (% of total land area) of Italy and Area (% of total land area) of Namibia?
Provide a succinct answer. 20.12. In the year 2005, what is the difference between the Area (% of total land area) of El Salvador and Area (% of total land area) of Israel?
Provide a succinct answer. 7.75. In the year 2005, what is the difference between the Area (% of total land area) of El Salvador and Area (% of total land area) of Italy?
Give a very brief answer. -14.87. In the year 2005, what is the difference between the Area (% of total land area) in El Salvador and Area (% of total land area) in Namibia?
Give a very brief answer. 5.61. In the year 2005, what is the difference between the Area (% of total land area) of Israel and Area (% of total land area) of Italy?
Your answer should be compact. -22.62. In the year 2005, what is the difference between the Area (% of total land area) of Israel and Area (% of total land area) of Namibia?
Make the answer very short. -2.14. In the year 2005, what is the difference between the Area (% of total land area) in Italy and Area (% of total land area) in Namibia?
Ensure brevity in your answer.  20.47. In the year 2006, what is the difference between the Area (% of total land area) in El Salvador and Area (% of total land area) in Israel?
Make the answer very short. 7.55. In the year 2006, what is the difference between the Area (% of total land area) in El Salvador and Area (% of total land area) in Italy?
Keep it short and to the point. -15.26. In the year 2006, what is the difference between the Area (% of total land area) in El Salvador and Area (% of total land area) in Namibia?
Ensure brevity in your answer.  5.49. In the year 2006, what is the difference between the Area (% of total land area) of Israel and Area (% of total land area) of Italy?
Offer a terse response. -22.81. In the year 2006, what is the difference between the Area (% of total land area) in Israel and Area (% of total land area) in Namibia?
Your answer should be compact. -2.06. In the year 2006, what is the difference between the Area (% of total land area) in Italy and Area (% of total land area) in Namibia?
Your answer should be compact. 20.75. In the year 2007, what is the difference between the Area (% of total land area) in El Salvador and Area (% of total land area) in Israel?
Ensure brevity in your answer.  7.34. In the year 2007, what is the difference between the Area (% of total land area) in El Salvador and Area (% of total land area) in Italy?
Make the answer very short. -15.66. In the year 2007, what is the difference between the Area (% of total land area) of El Salvador and Area (% of total land area) of Namibia?
Provide a succinct answer. 5.36. In the year 2007, what is the difference between the Area (% of total land area) of Israel and Area (% of total land area) of Italy?
Give a very brief answer. -23. In the year 2007, what is the difference between the Area (% of total land area) in Israel and Area (% of total land area) in Namibia?
Ensure brevity in your answer.  -1.98. In the year 2007, what is the difference between the Area (% of total land area) in Italy and Area (% of total land area) in Namibia?
Provide a short and direct response. 21.02. What is the ratio of the Area (% of total land area) in El Salvador in 2000 to that in 2001?
Give a very brief answer. 1.01. What is the ratio of the Area (% of total land area) of Israel in 2000 to that in 2001?
Offer a terse response. 1. What is the ratio of the Area (% of total land area) in Italy in 2000 to that in 2001?
Offer a terse response. 0.99. What is the ratio of the Area (% of total land area) of Namibia in 2000 to that in 2001?
Your answer should be compact. 1.01. What is the ratio of the Area (% of total land area) of El Salvador in 2000 to that in 2002?
Offer a very short reply. 1.03. What is the ratio of the Area (% of total land area) in Italy in 2000 to that in 2002?
Give a very brief answer. 0.98. What is the ratio of the Area (% of total land area) of Namibia in 2000 to that in 2002?
Offer a terse response. 1.02. What is the ratio of the Area (% of total land area) of El Salvador in 2000 to that in 2003?
Your answer should be very brief. 1.04. What is the ratio of the Area (% of total land area) in Israel in 2000 to that in 2003?
Give a very brief answer. 0.99. What is the ratio of the Area (% of total land area) of Italy in 2000 to that in 2003?
Offer a terse response. 0.97. What is the ratio of the Area (% of total land area) of Namibia in 2000 to that in 2003?
Ensure brevity in your answer.  1.03. What is the ratio of the Area (% of total land area) of El Salvador in 2000 to that in 2004?
Your answer should be compact. 1.06. What is the ratio of the Area (% of total land area) of Italy in 2000 to that in 2004?
Keep it short and to the point. 0.96. What is the ratio of the Area (% of total land area) in Namibia in 2000 to that in 2004?
Your response must be concise. 1.04. What is the ratio of the Area (% of total land area) of El Salvador in 2000 to that in 2005?
Ensure brevity in your answer.  1.07. What is the ratio of the Area (% of total land area) in Israel in 2000 to that in 2005?
Offer a terse response. 0.99. What is the ratio of the Area (% of total land area) of Italy in 2000 to that in 2005?
Provide a short and direct response. 0.96. What is the ratio of the Area (% of total land area) of Namibia in 2000 to that in 2005?
Offer a very short reply. 1.05. What is the ratio of the Area (% of total land area) of El Salvador in 2000 to that in 2006?
Your response must be concise. 1.09. What is the ratio of the Area (% of total land area) in Israel in 2000 to that in 2006?
Give a very brief answer. 0.99. What is the ratio of the Area (% of total land area) of Italy in 2000 to that in 2006?
Make the answer very short. 0.95. What is the ratio of the Area (% of total land area) of Namibia in 2000 to that in 2006?
Your answer should be very brief. 1.06. What is the ratio of the Area (% of total land area) of El Salvador in 2000 to that in 2007?
Give a very brief answer. 1.11. What is the ratio of the Area (% of total land area) in Italy in 2000 to that in 2007?
Give a very brief answer. 0.94. What is the ratio of the Area (% of total land area) in Namibia in 2000 to that in 2007?
Provide a succinct answer. 1.07. What is the ratio of the Area (% of total land area) of El Salvador in 2001 to that in 2002?
Provide a succinct answer. 1.01. What is the ratio of the Area (% of total land area) in Italy in 2001 to that in 2002?
Offer a terse response. 0.99. What is the ratio of the Area (% of total land area) in Namibia in 2001 to that in 2002?
Your response must be concise. 1.01. What is the ratio of the Area (% of total land area) of El Salvador in 2001 to that in 2003?
Give a very brief answer. 1.03. What is the ratio of the Area (% of total land area) in Italy in 2001 to that in 2003?
Ensure brevity in your answer.  0.98. What is the ratio of the Area (% of total land area) in El Salvador in 2001 to that in 2004?
Offer a very short reply. 1.04. What is the ratio of the Area (% of total land area) in Israel in 2001 to that in 2004?
Provide a succinct answer. 0.99. What is the ratio of the Area (% of total land area) in Italy in 2001 to that in 2004?
Give a very brief answer. 0.97. What is the ratio of the Area (% of total land area) in Namibia in 2001 to that in 2004?
Offer a terse response. 1.03. What is the ratio of the Area (% of total land area) of El Salvador in 2001 to that in 2005?
Give a very brief answer. 1.06. What is the ratio of the Area (% of total land area) of Italy in 2001 to that in 2005?
Ensure brevity in your answer.  0.96. What is the ratio of the Area (% of total land area) in Namibia in 2001 to that in 2005?
Make the answer very short. 1.04. What is the ratio of the Area (% of total land area) of El Salvador in 2001 to that in 2006?
Ensure brevity in your answer.  1.07. What is the ratio of the Area (% of total land area) of Israel in 2001 to that in 2006?
Provide a succinct answer. 0.99. What is the ratio of the Area (% of total land area) of Italy in 2001 to that in 2006?
Keep it short and to the point. 0.96. What is the ratio of the Area (% of total land area) of Namibia in 2001 to that in 2006?
Provide a short and direct response. 1.05. What is the ratio of the Area (% of total land area) of El Salvador in 2001 to that in 2007?
Your answer should be compact. 1.09. What is the ratio of the Area (% of total land area) in Italy in 2001 to that in 2007?
Keep it short and to the point. 0.95. What is the ratio of the Area (% of total land area) in Namibia in 2001 to that in 2007?
Your response must be concise. 1.06. What is the ratio of the Area (% of total land area) in El Salvador in 2002 to that in 2003?
Keep it short and to the point. 1.01. What is the ratio of the Area (% of total land area) of Israel in 2002 to that in 2003?
Ensure brevity in your answer.  1. What is the ratio of the Area (% of total land area) in Italy in 2002 to that in 2003?
Ensure brevity in your answer.  0.99. What is the ratio of the Area (% of total land area) in Namibia in 2002 to that in 2003?
Your answer should be compact. 1.01. What is the ratio of the Area (% of total land area) in El Salvador in 2002 to that in 2004?
Your response must be concise. 1.03. What is the ratio of the Area (% of total land area) of Israel in 2002 to that in 2004?
Provide a short and direct response. 0.99. What is the ratio of the Area (% of total land area) of Italy in 2002 to that in 2004?
Provide a succinct answer. 0.98. What is the ratio of the Area (% of total land area) of Namibia in 2002 to that in 2004?
Give a very brief answer. 1.02. What is the ratio of the Area (% of total land area) of El Salvador in 2002 to that in 2005?
Give a very brief answer. 1.04. What is the ratio of the Area (% of total land area) of Italy in 2002 to that in 2005?
Offer a very short reply. 0.97. What is the ratio of the Area (% of total land area) of Namibia in 2002 to that in 2005?
Ensure brevity in your answer.  1.03. What is the ratio of the Area (% of total land area) in El Salvador in 2002 to that in 2006?
Provide a short and direct response. 1.06. What is the ratio of the Area (% of total land area) in Italy in 2002 to that in 2006?
Offer a terse response. 0.97. What is the ratio of the Area (% of total land area) of Namibia in 2002 to that in 2006?
Make the answer very short. 1.04. What is the ratio of the Area (% of total land area) of El Salvador in 2002 to that in 2007?
Provide a short and direct response. 1.08. What is the ratio of the Area (% of total land area) of Italy in 2002 to that in 2007?
Ensure brevity in your answer.  0.96. What is the ratio of the Area (% of total land area) of Namibia in 2002 to that in 2007?
Your answer should be very brief. 1.05. What is the ratio of the Area (% of total land area) of El Salvador in 2003 to that in 2004?
Offer a terse response. 1.01. What is the ratio of the Area (% of total land area) in Israel in 2003 to that in 2004?
Keep it short and to the point. 1. What is the ratio of the Area (% of total land area) in Namibia in 2003 to that in 2004?
Keep it short and to the point. 1.01. What is the ratio of the Area (% of total land area) in El Salvador in 2003 to that in 2005?
Your response must be concise. 1.03. What is the ratio of the Area (% of total land area) of Israel in 2003 to that in 2005?
Make the answer very short. 0.99. What is the ratio of the Area (% of total land area) of Italy in 2003 to that in 2005?
Your answer should be very brief. 0.98. What is the ratio of the Area (% of total land area) in Namibia in 2003 to that in 2005?
Your response must be concise. 1.02. What is the ratio of the Area (% of total land area) in El Salvador in 2003 to that in 2006?
Your response must be concise. 1.04. What is the ratio of the Area (% of total land area) in Israel in 2003 to that in 2006?
Make the answer very short. 1. What is the ratio of the Area (% of total land area) of Italy in 2003 to that in 2006?
Your answer should be compact. 0.98. What is the ratio of the Area (% of total land area) of Namibia in 2003 to that in 2006?
Give a very brief answer. 1.03. What is the ratio of the Area (% of total land area) in El Salvador in 2003 to that in 2007?
Ensure brevity in your answer.  1.06. What is the ratio of the Area (% of total land area) of Italy in 2003 to that in 2007?
Your answer should be very brief. 0.97. What is the ratio of the Area (% of total land area) in Namibia in 2003 to that in 2007?
Your response must be concise. 1.04. What is the ratio of the Area (% of total land area) in El Salvador in 2004 to that in 2005?
Give a very brief answer. 1.01. What is the ratio of the Area (% of total land area) in Namibia in 2004 to that in 2005?
Provide a short and direct response. 1.01. What is the ratio of the Area (% of total land area) of El Salvador in 2004 to that in 2006?
Keep it short and to the point. 1.03. What is the ratio of the Area (% of total land area) of Namibia in 2004 to that in 2006?
Give a very brief answer. 1.02. What is the ratio of the Area (% of total land area) of El Salvador in 2004 to that in 2007?
Your response must be concise. 1.04. What is the ratio of the Area (% of total land area) of Israel in 2004 to that in 2007?
Offer a terse response. 1. What is the ratio of the Area (% of total land area) of Italy in 2004 to that in 2007?
Make the answer very short. 0.98. What is the ratio of the Area (% of total land area) of Namibia in 2004 to that in 2007?
Ensure brevity in your answer.  1.03. What is the ratio of the Area (% of total land area) of El Salvador in 2005 to that in 2006?
Make the answer very short. 1.01. What is the ratio of the Area (% of total land area) in Israel in 2005 to that in 2006?
Ensure brevity in your answer.  1. What is the ratio of the Area (% of total land area) of Namibia in 2005 to that in 2006?
Your answer should be very brief. 1.01. What is the ratio of the Area (% of total land area) of El Salvador in 2005 to that in 2007?
Your answer should be very brief. 1.03. What is the ratio of the Area (% of total land area) of Italy in 2005 to that in 2007?
Your answer should be very brief. 0.99. What is the ratio of the Area (% of total land area) in Namibia in 2005 to that in 2007?
Give a very brief answer. 1.02. What is the ratio of the Area (% of total land area) of El Salvador in 2006 to that in 2007?
Make the answer very short. 1.01. What is the ratio of the Area (% of total land area) of Israel in 2006 to that in 2007?
Your answer should be compact. 1. What is the ratio of the Area (% of total land area) of Namibia in 2006 to that in 2007?
Provide a short and direct response. 1.01. What is the difference between the highest and the second highest Area (% of total land area) in El Salvador?
Ensure brevity in your answer.  0.22. What is the difference between the highest and the second highest Area (% of total land area) of Israel?
Make the answer very short. 0.01. What is the difference between the highest and the second highest Area (% of total land area) in Italy?
Your answer should be compact. 0.18. What is the difference between the highest and the second highest Area (% of total land area) in Namibia?
Give a very brief answer. 0.09. What is the difference between the highest and the lowest Area (% of total land area) in El Salvador?
Provide a short and direct response. 1.53. What is the difference between the highest and the lowest Area (% of total land area) in Israel?
Provide a succinct answer. 0.09. What is the difference between the highest and the lowest Area (% of total land area) of Italy?
Provide a short and direct response. 1.69. What is the difference between the highest and the lowest Area (% of total land area) of Namibia?
Make the answer very short. 0.63. 